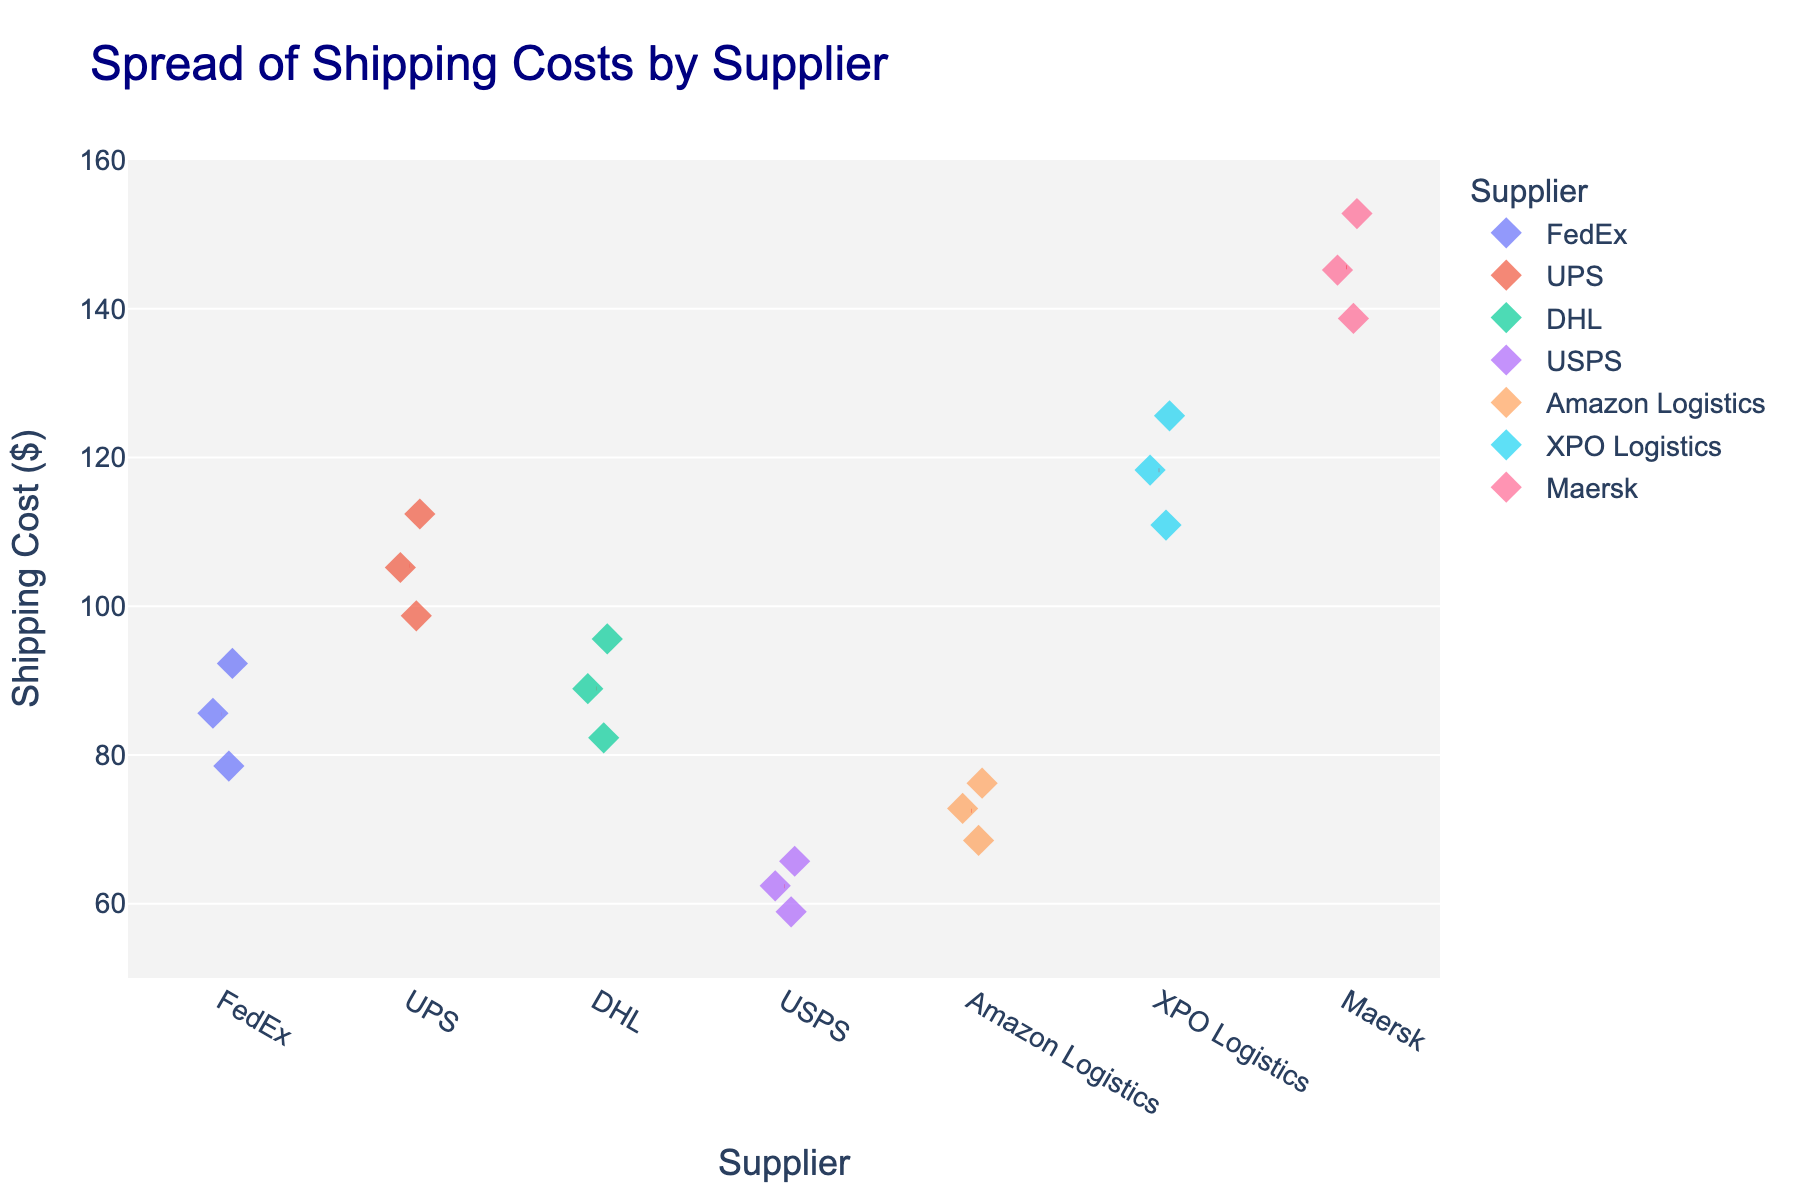Which supplier has the highest average shipping cost? The average shipping cost is indicated by red dashed lines. By comparing the height of these lines, we can see that Maersk's line is positioned the highest.
Answer: Maersk What is the range of shipping costs for USPS? Identify the lowest and highest points for USPS. The lowest point is at $58.90 and the highest is at $65.70. Subtract the lowest from the highest to get the range: $65.70 - $58.90 = $6.80
Answer: $6.80 How many data points are there for Amazon Logistics? Count the diamond markers in the plot corresponding to Amazon Logistics. There are three markers.
Answer: 3 Which supplier has the most spread in their shipping costs? The spread can be assessed by the range between the lowest and highest data points for each supplier. XPO Logistics appears to have the widest spread, ranging from approximately $110.90 to $125.60.
Answer: XPO Logistics Which supplier has the lowest single shipping cost value? The lowest single shipping cost value can be identified by finding the lowest point on the y-axis across all suppliers. USPS has the lowest point at $58.90.
Answer: USPS Compare the average shipping cost of FedEx and UPS. Which one is lower? Look at the red dashed lines representing the average costs for both FedEx and UPS. FedEx's line is lower than UPS's, indicating FedEx's average is lower.
Answer: FedEx What is the overall mean shipping cost for all the suppliers combined? Sum up all the shipping costs: 78.50 + 92.30 + 85.60 + 105.20 + 98.70 + 112.40 + 88.90 + 95.60 + 82.30 + 62.40 + 58.90 + 65.70 + 72.80 + 68.50 + 76.20 + 118.30 + 125.60 + 110.90 + 145.20 + 138.70 + 152.80 = 1994.10. Divide by the number of data points, which is 21: 1994.10 / 21 ≈ 94.96.
Answer: 94.96 For which supplier is the mean shipping cost closest to $85? Compare the red dashed lines to the $85 mark on the y-axis. FedEx’s mean shipping cost is the closest to $85.
Answer: FedEx 